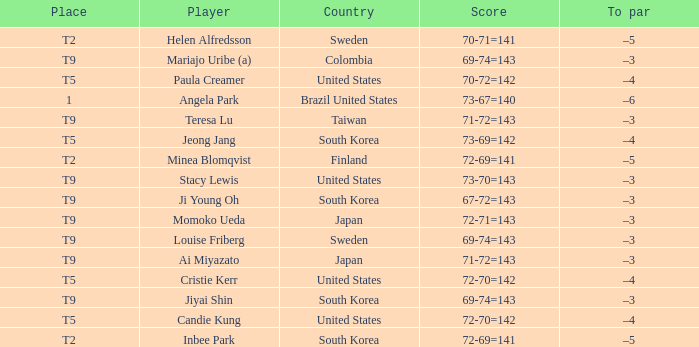What was Momoko Ueda's place? T9. 